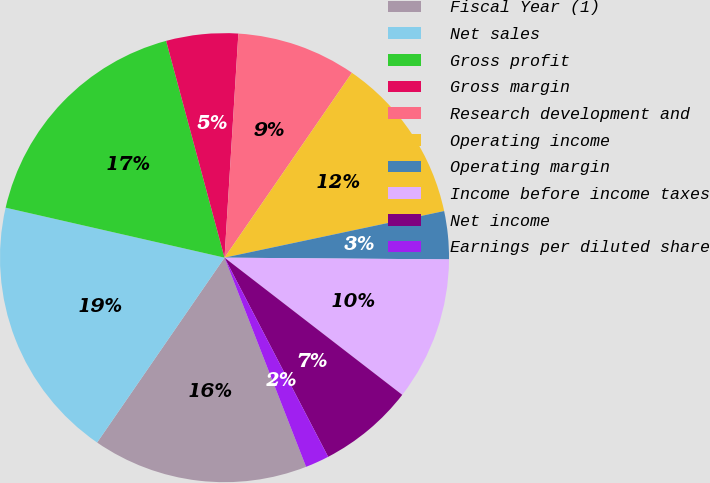Convert chart. <chart><loc_0><loc_0><loc_500><loc_500><pie_chart><fcel>Fiscal Year (1)<fcel>Net sales<fcel>Gross profit<fcel>Gross margin<fcel>Research development and<fcel>Operating income<fcel>Operating margin<fcel>Income before income taxes<fcel>Net income<fcel>Earnings per diluted share<nl><fcel>15.52%<fcel>18.97%<fcel>17.24%<fcel>5.17%<fcel>8.62%<fcel>12.07%<fcel>3.45%<fcel>10.34%<fcel>6.9%<fcel>1.72%<nl></chart> 